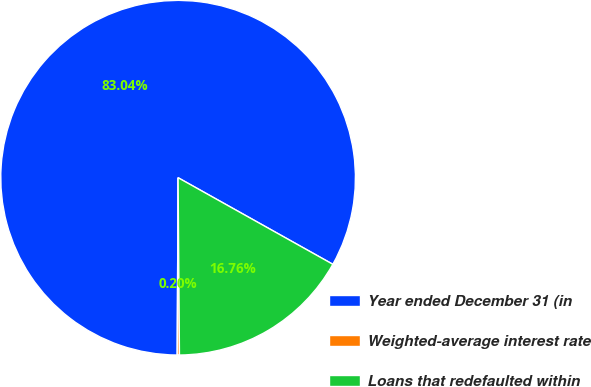Convert chart to OTSL. <chart><loc_0><loc_0><loc_500><loc_500><pie_chart><fcel>Year ended December 31 (in<fcel>Weighted-average interest rate<fcel>Loans that redefaulted within<nl><fcel>83.04%<fcel>0.2%<fcel>16.76%<nl></chart> 